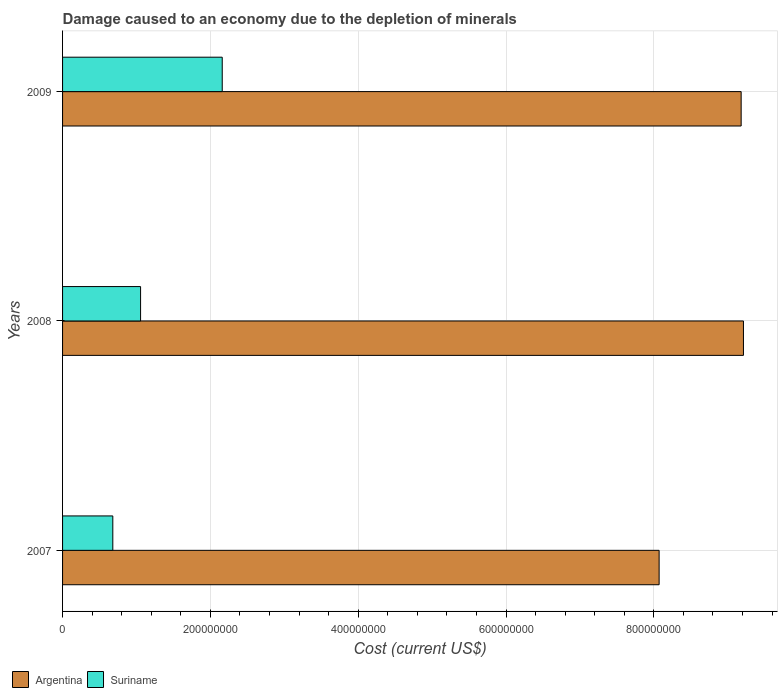How many bars are there on the 2nd tick from the top?
Ensure brevity in your answer.  2. What is the label of the 3rd group of bars from the top?
Ensure brevity in your answer.  2007. In how many cases, is the number of bars for a given year not equal to the number of legend labels?
Keep it short and to the point. 0. What is the cost of damage caused due to the depletion of minerals in Argentina in 2009?
Keep it short and to the point. 9.18e+08. Across all years, what is the maximum cost of damage caused due to the depletion of minerals in Argentina?
Provide a short and direct response. 9.21e+08. Across all years, what is the minimum cost of damage caused due to the depletion of minerals in Suriname?
Keep it short and to the point. 6.80e+07. In which year was the cost of damage caused due to the depletion of minerals in Argentina maximum?
Your answer should be compact. 2008. What is the total cost of damage caused due to the depletion of minerals in Argentina in the graph?
Give a very brief answer. 2.65e+09. What is the difference between the cost of damage caused due to the depletion of minerals in Argentina in 2007 and that in 2009?
Your response must be concise. -1.11e+08. What is the difference between the cost of damage caused due to the depletion of minerals in Argentina in 2009 and the cost of damage caused due to the depletion of minerals in Suriname in 2007?
Give a very brief answer. 8.50e+08. What is the average cost of damage caused due to the depletion of minerals in Argentina per year?
Give a very brief answer. 8.82e+08. In the year 2008, what is the difference between the cost of damage caused due to the depletion of minerals in Suriname and cost of damage caused due to the depletion of minerals in Argentina?
Provide a succinct answer. -8.16e+08. In how many years, is the cost of damage caused due to the depletion of minerals in Suriname greater than 560000000 US$?
Make the answer very short. 0. What is the ratio of the cost of damage caused due to the depletion of minerals in Suriname in 2008 to that in 2009?
Offer a very short reply. 0.49. What is the difference between the highest and the second highest cost of damage caused due to the depletion of minerals in Suriname?
Give a very brief answer. 1.11e+08. What is the difference between the highest and the lowest cost of damage caused due to the depletion of minerals in Suriname?
Ensure brevity in your answer.  1.48e+08. In how many years, is the cost of damage caused due to the depletion of minerals in Suriname greater than the average cost of damage caused due to the depletion of minerals in Suriname taken over all years?
Your answer should be compact. 1. Is the sum of the cost of damage caused due to the depletion of minerals in Argentina in 2007 and 2009 greater than the maximum cost of damage caused due to the depletion of minerals in Suriname across all years?
Your response must be concise. Yes. What does the 1st bar from the top in 2007 represents?
Give a very brief answer. Suriname. What does the 2nd bar from the bottom in 2009 represents?
Offer a terse response. Suriname. How many bars are there?
Your answer should be compact. 6. Are the values on the major ticks of X-axis written in scientific E-notation?
Provide a succinct answer. No. Does the graph contain grids?
Provide a short and direct response. Yes. How are the legend labels stacked?
Ensure brevity in your answer.  Horizontal. What is the title of the graph?
Your answer should be very brief. Damage caused to an economy due to the depletion of minerals. Does "East Asia (all income levels)" appear as one of the legend labels in the graph?
Make the answer very short. No. What is the label or title of the X-axis?
Provide a succinct answer. Cost (current US$). What is the Cost (current US$) in Argentina in 2007?
Keep it short and to the point. 8.07e+08. What is the Cost (current US$) of Suriname in 2007?
Keep it short and to the point. 6.80e+07. What is the Cost (current US$) of Argentina in 2008?
Your answer should be very brief. 9.21e+08. What is the Cost (current US$) of Suriname in 2008?
Give a very brief answer. 1.06e+08. What is the Cost (current US$) of Argentina in 2009?
Your answer should be very brief. 9.18e+08. What is the Cost (current US$) in Suriname in 2009?
Keep it short and to the point. 2.16e+08. Across all years, what is the maximum Cost (current US$) of Argentina?
Keep it short and to the point. 9.21e+08. Across all years, what is the maximum Cost (current US$) of Suriname?
Offer a very short reply. 2.16e+08. Across all years, what is the minimum Cost (current US$) of Argentina?
Give a very brief answer. 8.07e+08. Across all years, what is the minimum Cost (current US$) of Suriname?
Your answer should be compact. 6.80e+07. What is the total Cost (current US$) in Argentina in the graph?
Give a very brief answer. 2.65e+09. What is the total Cost (current US$) of Suriname in the graph?
Keep it short and to the point. 3.90e+08. What is the difference between the Cost (current US$) in Argentina in 2007 and that in 2008?
Make the answer very short. -1.14e+08. What is the difference between the Cost (current US$) in Suriname in 2007 and that in 2008?
Make the answer very short. -3.76e+07. What is the difference between the Cost (current US$) in Argentina in 2007 and that in 2009?
Your response must be concise. -1.11e+08. What is the difference between the Cost (current US$) in Suriname in 2007 and that in 2009?
Your answer should be compact. -1.48e+08. What is the difference between the Cost (current US$) of Argentina in 2008 and that in 2009?
Ensure brevity in your answer.  3.11e+06. What is the difference between the Cost (current US$) in Suriname in 2008 and that in 2009?
Provide a succinct answer. -1.11e+08. What is the difference between the Cost (current US$) of Argentina in 2007 and the Cost (current US$) of Suriname in 2008?
Provide a short and direct response. 7.02e+08. What is the difference between the Cost (current US$) in Argentina in 2007 and the Cost (current US$) in Suriname in 2009?
Offer a terse response. 5.91e+08. What is the difference between the Cost (current US$) of Argentina in 2008 and the Cost (current US$) of Suriname in 2009?
Offer a terse response. 7.05e+08. What is the average Cost (current US$) of Argentina per year?
Ensure brevity in your answer.  8.82e+08. What is the average Cost (current US$) in Suriname per year?
Provide a short and direct response. 1.30e+08. In the year 2007, what is the difference between the Cost (current US$) in Argentina and Cost (current US$) in Suriname?
Your answer should be compact. 7.39e+08. In the year 2008, what is the difference between the Cost (current US$) in Argentina and Cost (current US$) in Suriname?
Your answer should be compact. 8.16e+08. In the year 2009, what is the difference between the Cost (current US$) in Argentina and Cost (current US$) in Suriname?
Offer a terse response. 7.02e+08. What is the ratio of the Cost (current US$) of Argentina in 2007 to that in 2008?
Provide a short and direct response. 0.88. What is the ratio of the Cost (current US$) in Suriname in 2007 to that in 2008?
Ensure brevity in your answer.  0.64. What is the ratio of the Cost (current US$) in Argentina in 2007 to that in 2009?
Ensure brevity in your answer.  0.88. What is the ratio of the Cost (current US$) in Suriname in 2007 to that in 2009?
Give a very brief answer. 0.31. What is the ratio of the Cost (current US$) in Suriname in 2008 to that in 2009?
Offer a very short reply. 0.49. What is the difference between the highest and the second highest Cost (current US$) in Argentina?
Ensure brevity in your answer.  3.11e+06. What is the difference between the highest and the second highest Cost (current US$) of Suriname?
Your response must be concise. 1.11e+08. What is the difference between the highest and the lowest Cost (current US$) in Argentina?
Offer a terse response. 1.14e+08. What is the difference between the highest and the lowest Cost (current US$) in Suriname?
Provide a succinct answer. 1.48e+08. 